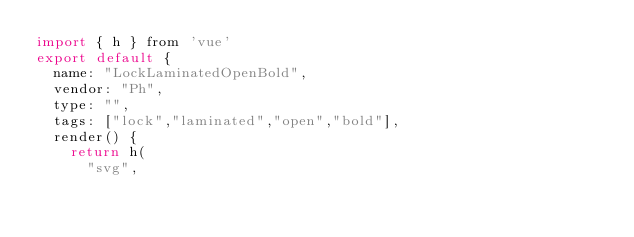Convert code to text. <code><loc_0><loc_0><loc_500><loc_500><_JavaScript_>import { h } from 'vue'
export default {
  name: "LockLaminatedOpenBold",
  vendor: "Ph",
  type: "",
  tags: ["lock","laminated","open","bold"],
  render() {
    return h(
      "svg",</code> 